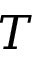<formula> <loc_0><loc_0><loc_500><loc_500>T</formula> 